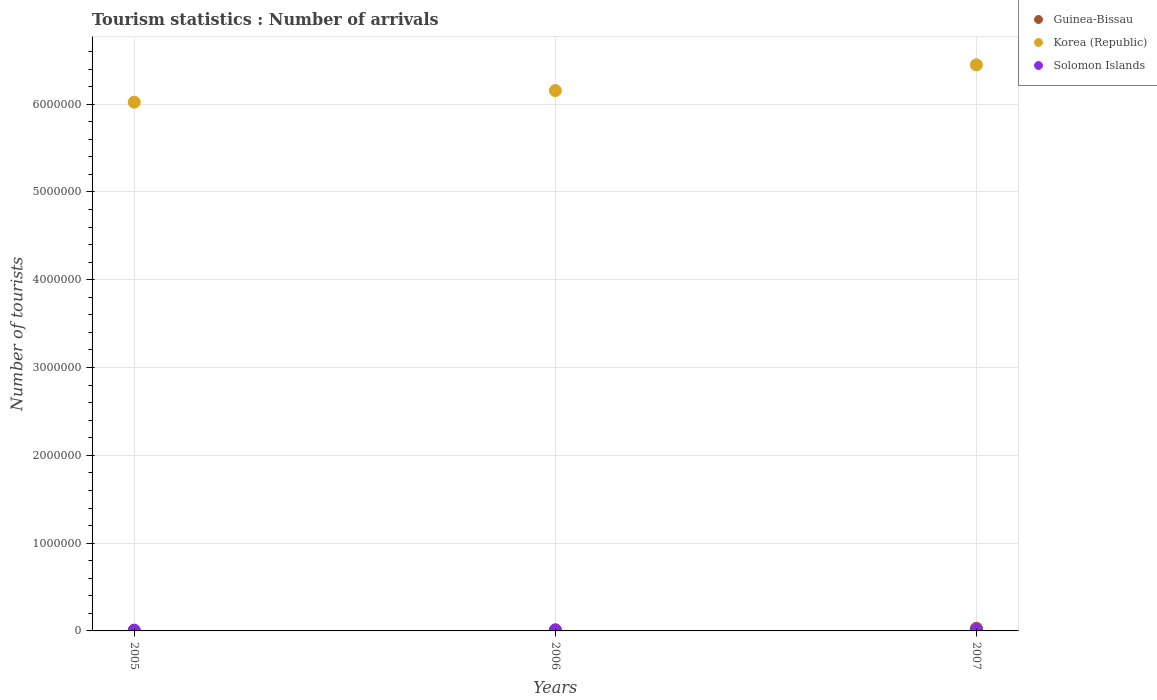Is the number of dotlines equal to the number of legend labels?
Your answer should be very brief. Yes. What is the number of tourist arrivals in Solomon Islands in 2005?
Offer a very short reply. 9000. Across all years, what is the maximum number of tourist arrivals in Solomon Islands?
Keep it short and to the point. 1.40e+04. Across all years, what is the minimum number of tourist arrivals in Guinea-Bissau?
Your response must be concise. 5000. What is the total number of tourist arrivals in Korea (Republic) in the graph?
Your answer should be compact. 1.86e+07. What is the difference between the number of tourist arrivals in Korea (Republic) in 2005 and that in 2007?
Your answer should be compact. -4.25e+05. What is the difference between the number of tourist arrivals in Solomon Islands in 2005 and the number of tourist arrivals in Guinea-Bissau in 2007?
Offer a very short reply. -2.10e+04. What is the average number of tourist arrivals in Guinea-Bissau per year?
Your answer should be very brief. 1.57e+04. In the year 2005, what is the difference between the number of tourist arrivals in Guinea-Bissau and number of tourist arrivals in Korea (Republic)?
Your answer should be very brief. -6.02e+06. What is the difference between the highest and the second highest number of tourist arrivals in Solomon Islands?
Provide a succinct answer. 3000. What is the difference between the highest and the lowest number of tourist arrivals in Korea (Republic)?
Your answer should be very brief. 4.25e+05. In how many years, is the number of tourist arrivals in Korea (Republic) greater than the average number of tourist arrivals in Korea (Republic) taken over all years?
Your answer should be compact. 1. Is it the case that in every year, the sum of the number of tourist arrivals in Korea (Republic) and number of tourist arrivals in Solomon Islands  is greater than the number of tourist arrivals in Guinea-Bissau?
Ensure brevity in your answer.  Yes. Does the number of tourist arrivals in Solomon Islands monotonically increase over the years?
Ensure brevity in your answer.  Yes. Is the number of tourist arrivals in Korea (Republic) strictly greater than the number of tourist arrivals in Guinea-Bissau over the years?
Give a very brief answer. Yes. Is the number of tourist arrivals in Solomon Islands strictly less than the number of tourist arrivals in Korea (Republic) over the years?
Offer a terse response. Yes. How many years are there in the graph?
Ensure brevity in your answer.  3. Does the graph contain any zero values?
Your response must be concise. No. Does the graph contain grids?
Offer a very short reply. Yes. How many legend labels are there?
Offer a terse response. 3. What is the title of the graph?
Ensure brevity in your answer.  Tourism statistics : Number of arrivals. What is the label or title of the X-axis?
Your answer should be compact. Years. What is the label or title of the Y-axis?
Your answer should be compact. Number of tourists. What is the Number of tourists of Korea (Republic) in 2005?
Your answer should be very brief. 6.02e+06. What is the Number of tourists in Solomon Islands in 2005?
Keep it short and to the point. 9000. What is the Number of tourists in Guinea-Bissau in 2006?
Your answer should be very brief. 1.20e+04. What is the Number of tourists of Korea (Republic) in 2006?
Offer a terse response. 6.16e+06. What is the Number of tourists of Solomon Islands in 2006?
Your answer should be compact. 1.10e+04. What is the Number of tourists of Korea (Republic) in 2007?
Ensure brevity in your answer.  6.45e+06. What is the Number of tourists in Solomon Islands in 2007?
Your answer should be compact. 1.40e+04. Across all years, what is the maximum Number of tourists of Korea (Republic)?
Give a very brief answer. 6.45e+06. Across all years, what is the maximum Number of tourists in Solomon Islands?
Offer a very short reply. 1.40e+04. Across all years, what is the minimum Number of tourists in Guinea-Bissau?
Keep it short and to the point. 5000. Across all years, what is the minimum Number of tourists in Korea (Republic)?
Provide a succinct answer. 6.02e+06. Across all years, what is the minimum Number of tourists of Solomon Islands?
Make the answer very short. 9000. What is the total Number of tourists of Guinea-Bissau in the graph?
Your response must be concise. 4.70e+04. What is the total Number of tourists in Korea (Republic) in the graph?
Make the answer very short. 1.86e+07. What is the total Number of tourists in Solomon Islands in the graph?
Your answer should be very brief. 3.40e+04. What is the difference between the Number of tourists of Guinea-Bissau in 2005 and that in 2006?
Make the answer very short. -7000. What is the difference between the Number of tourists in Korea (Republic) in 2005 and that in 2006?
Make the answer very short. -1.32e+05. What is the difference between the Number of tourists of Solomon Islands in 2005 and that in 2006?
Ensure brevity in your answer.  -2000. What is the difference between the Number of tourists of Guinea-Bissau in 2005 and that in 2007?
Your response must be concise. -2.50e+04. What is the difference between the Number of tourists of Korea (Republic) in 2005 and that in 2007?
Offer a terse response. -4.25e+05. What is the difference between the Number of tourists of Solomon Islands in 2005 and that in 2007?
Ensure brevity in your answer.  -5000. What is the difference between the Number of tourists in Guinea-Bissau in 2006 and that in 2007?
Provide a short and direct response. -1.80e+04. What is the difference between the Number of tourists of Korea (Republic) in 2006 and that in 2007?
Offer a very short reply. -2.93e+05. What is the difference between the Number of tourists in Solomon Islands in 2006 and that in 2007?
Give a very brief answer. -3000. What is the difference between the Number of tourists of Guinea-Bissau in 2005 and the Number of tourists of Korea (Republic) in 2006?
Give a very brief answer. -6.15e+06. What is the difference between the Number of tourists in Guinea-Bissau in 2005 and the Number of tourists in Solomon Islands in 2006?
Provide a short and direct response. -6000. What is the difference between the Number of tourists in Korea (Republic) in 2005 and the Number of tourists in Solomon Islands in 2006?
Offer a very short reply. 6.01e+06. What is the difference between the Number of tourists of Guinea-Bissau in 2005 and the Number of tourists of Korea (Republic) in 2007?
Make the answer very short. -6.44e+06. What is the difference between the Number of tourists of Guinea-Bissau in 2005 and the Number of tourists of Solomon Islands in 2007?
Give a very brief answer. -9000. What is the difference between the Number of tourists in Korea (Republic) in 2005 and the Number of tourists in Solomon Islands in 2007?
Provide a short and direct response. 6.01e+06. What is the difference between the Number of tourists of Guinea-Bissau in 2006 and the Number of tourists of Korea (Republic) in 2007?
Your answer should be compact. -6.44e+06. What is the difference between the Number of tourists in Guinea-Bissau in 2006 and the Number of tourists in Solomon Islands in 2007?
Provide a succinct answer. -2000. What is the difference between the Number of tourists of Korea (Republic) in 2006 and the Number of tourists of Solomon Islands in 2007?
Make the answer very short. 6.14e+06. What is the average Number of tourists of Guinea-Bissau per year?
Ensure brevity in your answer.  1.57e+04. What is the average Number of tourists of Korea (Republic) per year?
Keep it short and to the point. 6.21e+06. What is the average Number of tourists in Solomon Islands per year?
Your answer should be compact. 1.13e+04. In the year 2005, what is the difference between the Number of tourists of Guinea-Bissau and Number of tourists of Korea (Republic)?
Offer a terse response. -6.02e+06. In the year 2005, what is the difference between the Number of tourists of Guinea-Bissau and Number of tourists of Solomon Islands?
Your answer should be compact. -4000. In the year 2005, what is the difference between the Number of tourists in Korea (Republic) and Number of tourists in Solomon Islands?
Your answer should be compact. 6.01e+06. In the year 2006, what is the difference between the Number of tourists of Guinea-Bissau and Number of tourists of Korea (Republic)?
Offer a terse response. -6.14e+06. In the year 2006, what is the difference between the Number of tourists of Guinea-Bissau and Number of tourists of Solomon Islands?
Your answer should be very brief. 1000. In the year 2006, what is the difference between the Number of tourists in Korea (Republic) and Number of tourists in Solomon Islands?
Provide a short and direct response. 6.14e+06. In the year 2007, what is the difference between the Number of tourists of Guinea-Bissau and Number of tourists of Korea (Republic)?
Give a very brief answer. -6.42e+06. In the year 2007, what is the difference between the Number of tourists of Guinea-Bissau and Number of tourists of Solomon Islands?
Ensure brevity in your answer.  1.60e+04. In the year 2007, what is the difference between the Number of tourists of Korea (Republic) and Number of tourists of Solomon Islands?
Offer a very short reply. 6.43e+06. What is the ratio of the Number of tourists in Guinea-Bissau in 2005 to that in 2006?
Your answer should be compact. 0.42. What is the ratio of the Number of tourists in Korea (Republic) in 2005 to that in 2006?
Your response must be concise. 0.98. What is the ratio of the Number of tourists of Solomon Islands in 2005 to that in 2006?
Your answer should be very brief. 0.82. What is the ratio of the Number of tourists of Korea (Republic) in 2005 to that in 2007?
Give a very brief answer. 0.93. What is the ratio of the Number of tourists in Solomon Islands in 2005 to that in 2007?
Ensure brevity in your answer.  0.64. What is the ratio of the Number of tourists in Korea (Republic) in 2006 to that in 2007?
Keep it short and to the point. 0.95. What is the ratio of the Number of tourists of Solomon Islands in 2006 to that in 2007?
Offer a terse response. 0.79. What is the difference between the highest and the second highest Number of tourists of Guinea-Bissau?
Your answer should be very brief. 1.80e+04. What is the difference between the highest and the second highest Number of tourists of Korea (Republic)?
Your answer should be compact. 2.93e+05. What is the difference between the highest and the second highest Number of tourists in Solomon Islands?
Make the answer very short. 3000. What is the difference between the highest and the lowest Number of tourists of Guinea-Bissau?
Your answer should be very brief. 2.50e+04. What is the difference between the highest and the lowest Number of tourists in Korea (Republic)?
Make the answer very short. 4.25e+05. 